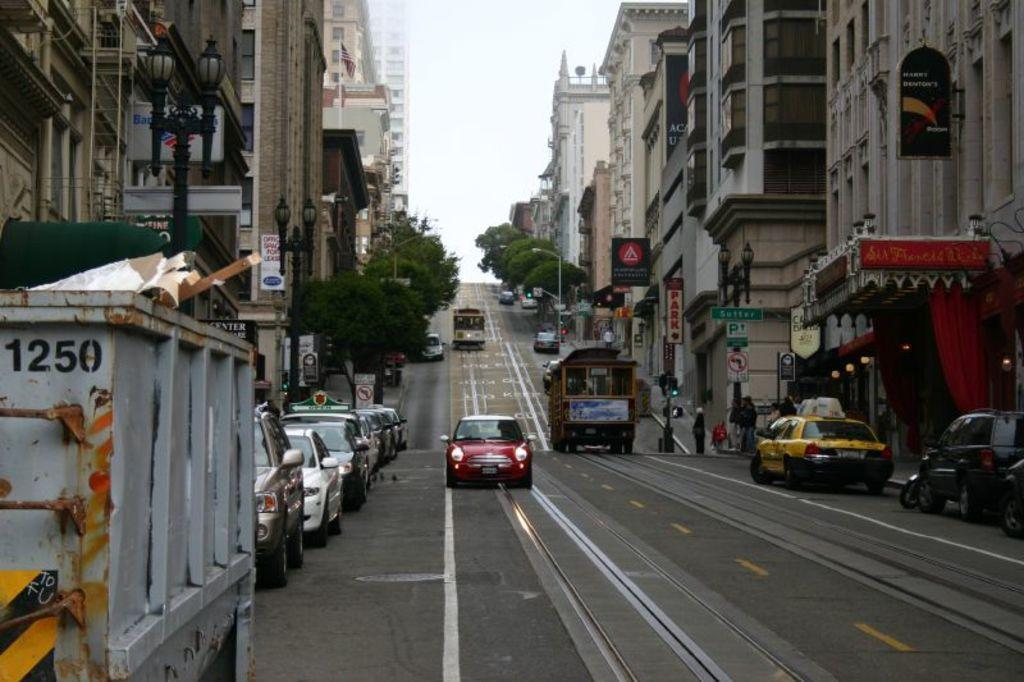<image>
Describe the image concisely. A calm street with many parked cars. To the side is a white dumpster that has the number 1250 on it. 